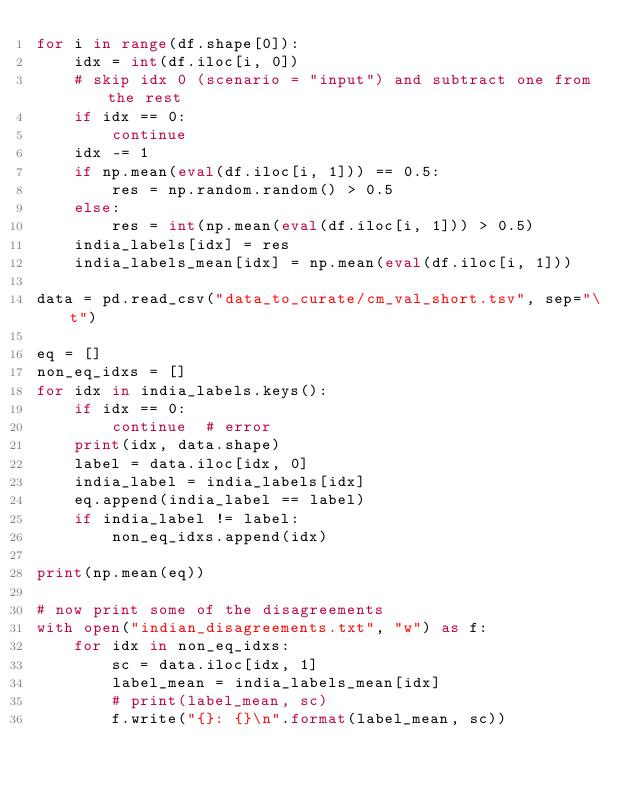Convert code to text. <code><loc_0><loc_0><loc_500><loc_500><_Python_>for i in range(df.shape[0]):
    idx = int(df.iloc[i, 0])
    # skip idx 0 (scenario = "input") and subtract one from the rest
    if idx == 0:
        continue
    idx -= 1
    if np.mean(eval(df.iloc[i, 1])) == 0.5:
        res = np.random.random() > 0.5
    else:
        res = int(np.mean(eval(df.iloc[i, 1])) > 0.5)
    india_labels[idx] = res
    india_labels_mean[idx] = np.mean(eval(df.iloc[i, 1]))

data = pd.read_csv("data_to_curate/cm_val_short.tsv", sep="\t")

eq = []
non_eq_idxs = []
for idx in india_labels.keys():
    if idx == 0:
        continue  # error
    print(idx, data.shape)
    label = data.iloc[idx, 0]
    india_label = india_labels[idx]
    eq.append(india_label == label)
    if india_label != label:
        non_eq_idxs.append(idx)

print(np.mean(eq))

# now print some of the disagreements
with open("indian_disagreements.txt", "w") as f:
    for idx in non_eq_idxs:
        sc = data.iloc[idx, 1]
        label_mean = india_labels_mean[idx]
        # print(label_mean, sc)
        f.write("{}: {}\n".format(label_mean, sc))

</code> 